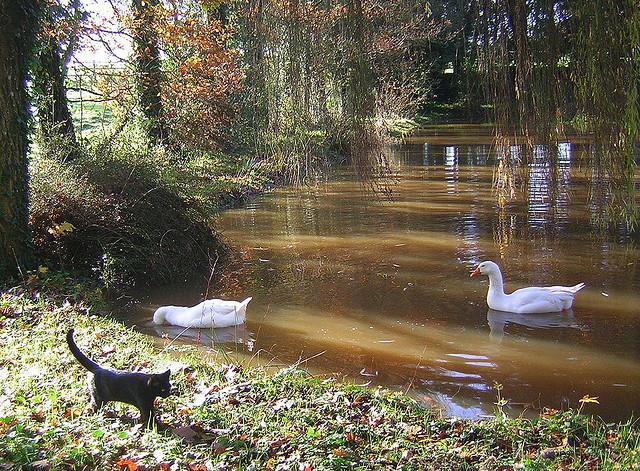How many birds can you see?
Give a very brief answer. 2. 